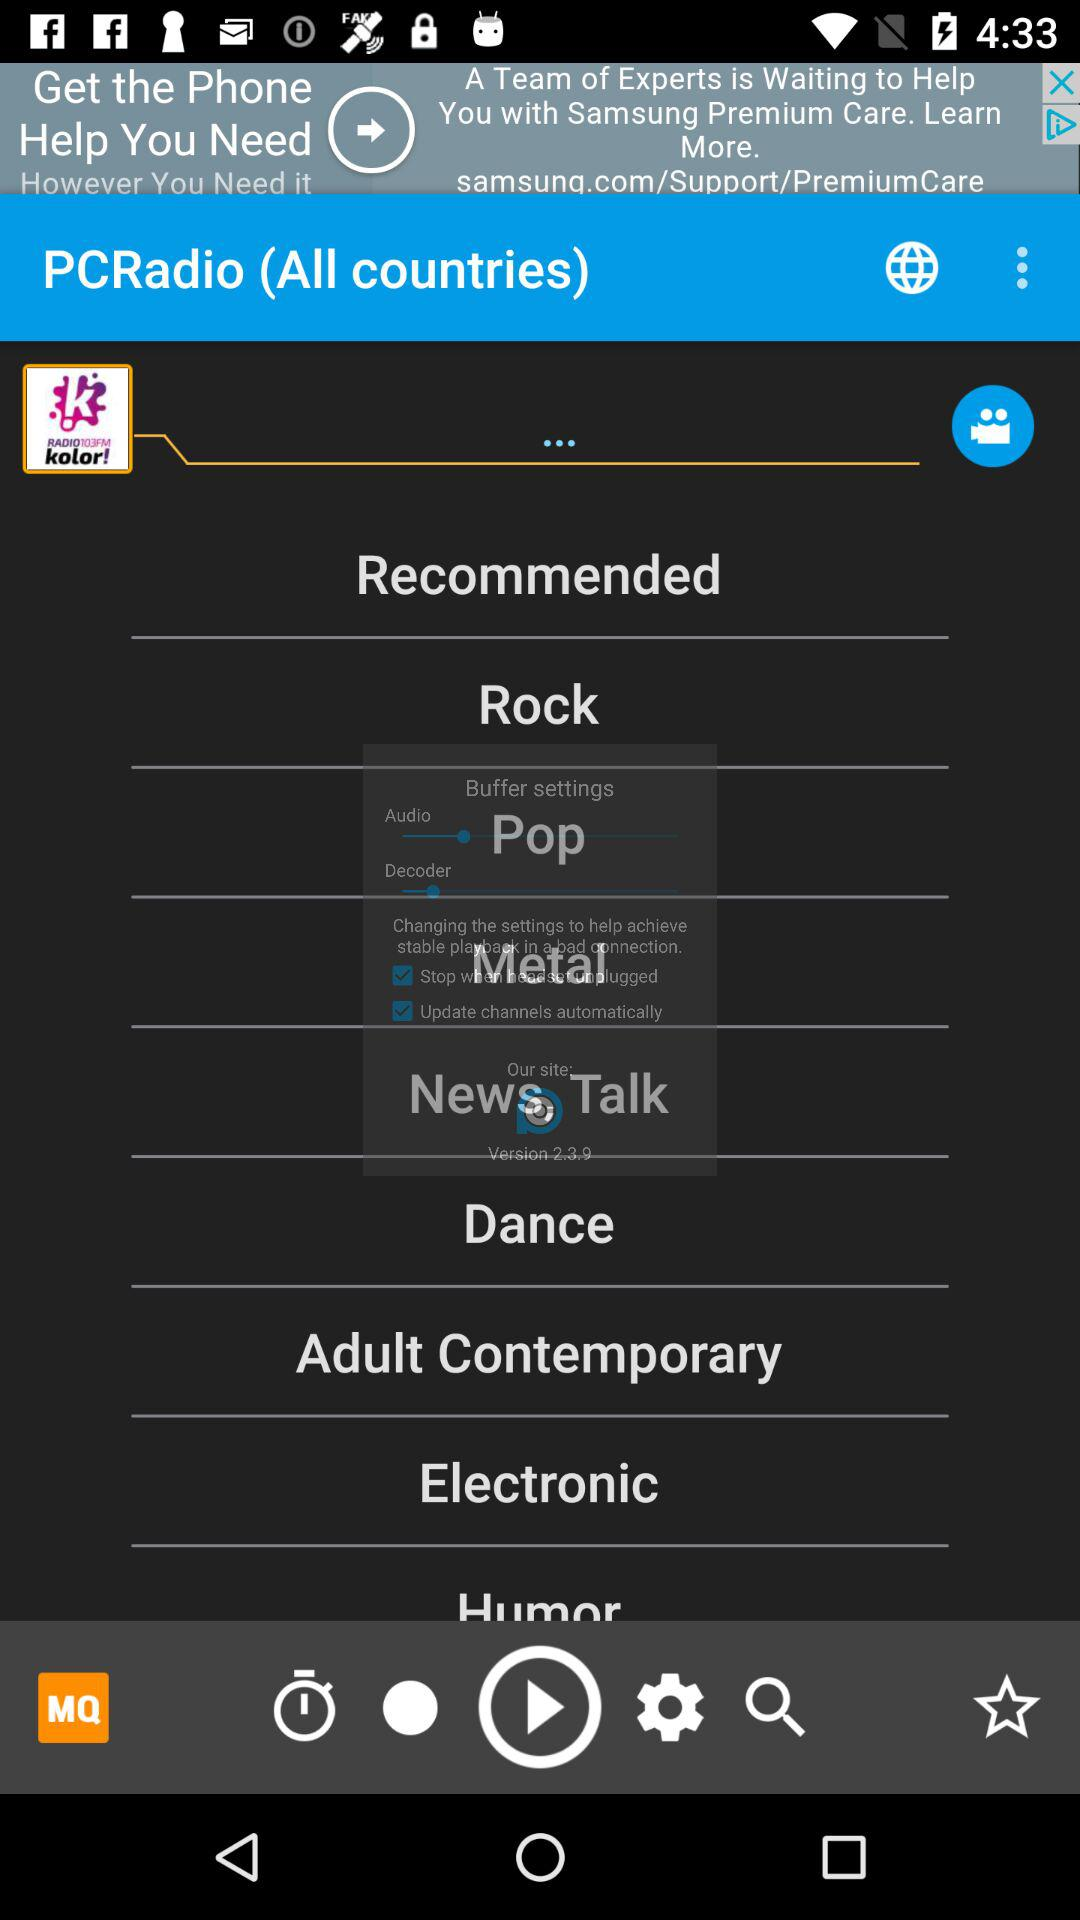What is the application name? The application name is "PCRadio". 